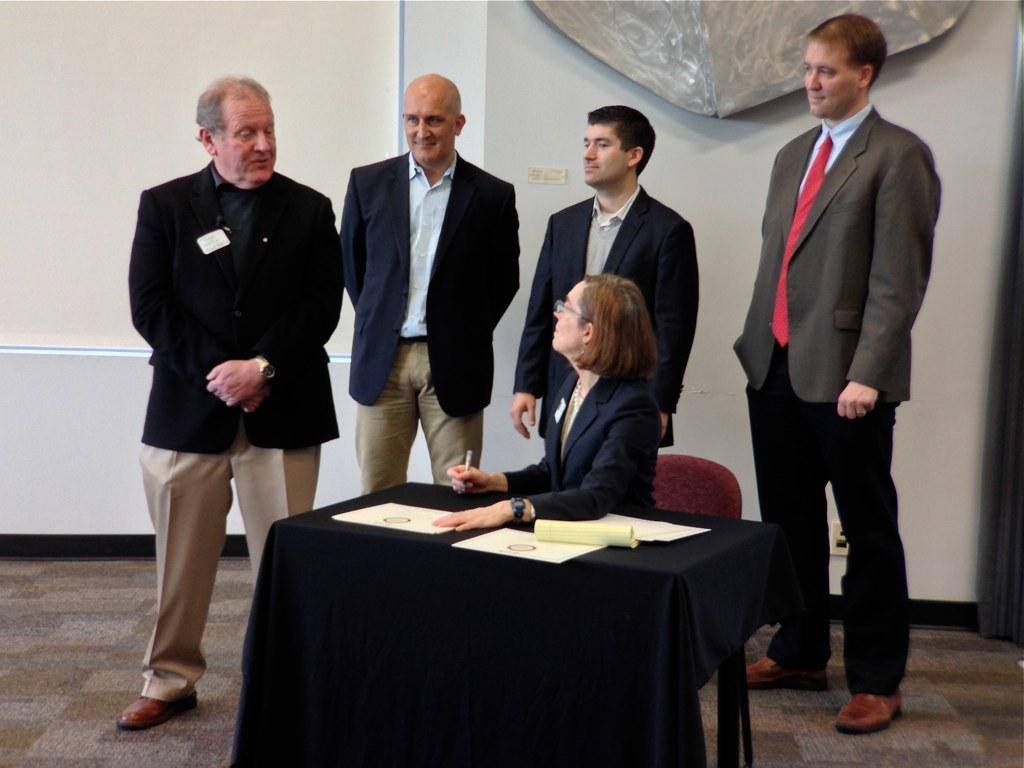How many people are present in the image? There are four persons standing in the image. What is the woman in the image doing? The woman is sitting on a chair in the image. Where is the woman located in relation to the table? The woman is around a table. What items can be seen on the table? There are papers and a pen on the table. What is visible in the background of the image? There is a wall in the background of the image. What type of patch is the woman sewing onto her shirt in the image? There is no patch or sewing activity present in the image. What flavor of soda is the woman drinking in the image? There is no soda present in the image. 